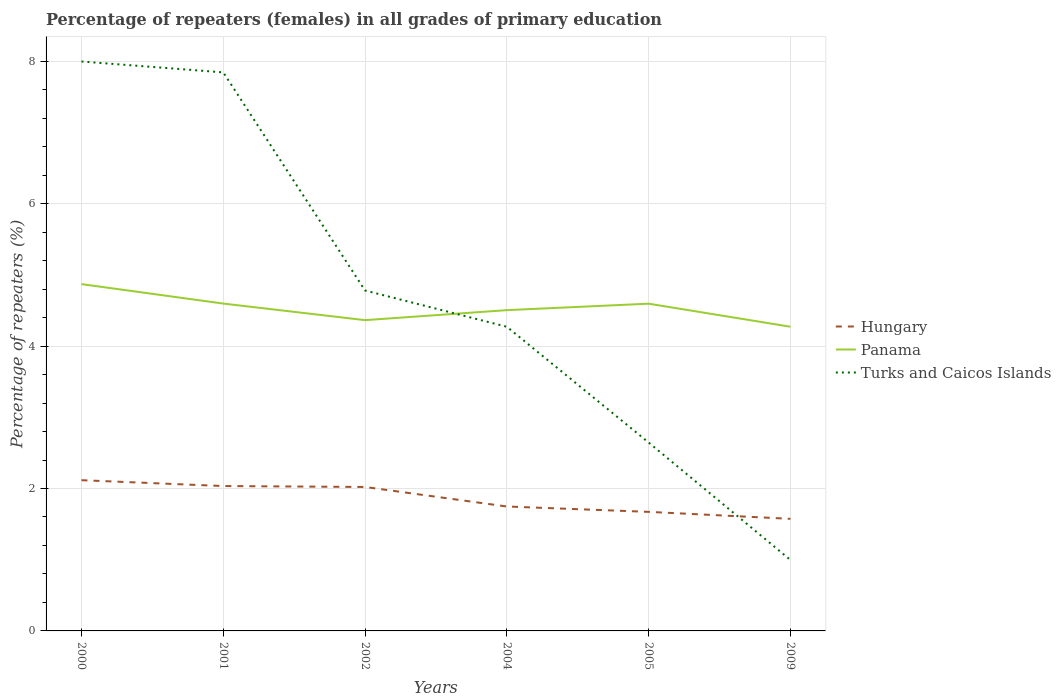Is the number of lines equal to the number of legend labels?
Provide a short and direct response. Yes. Across all years, what is the maximum percentage of repeaters (females) in Panama?
Provide a short and direct response. 4.27. In which year was the percentage of repeaters (females) in Hungary maximum?
Make the answer very short. 2009. What is the total percentage of repeaters (females) in Hungary in the graph?
Provide a short and direct response. 0.45. What is the difference between the highest and the second highest percentage of repeaters (females) in Hungary?
Provide a short and direct response. 0.54. Is the percentage of repeaters (females) in Turks and Caicos Islands strictly greater than the percentage of repeaters (females) in Hungary over the years?
Your answer should be compact. No. How many lines are there?
Your response must be concise. 3. How many years are there in the graph?
Provide a short and direct response. 6. What is the difference between two consecutive major ticks on the Y-axis?
Make the answer very short. 2. Does the graph contain grids?
Make the answer very short. Yes. How many legend labels are there?
Your response must be concise. 3. What is the title of the graph?
Keep it short and to the point. Percentage of repeaters (females) in all grades of primary education. What is the label or title of the X-axis?
Provide a short and direct response. Years. What is the label or title of the Y-axis?
Make the answer very short. Percentage of repeaters (%). What is the Percentage of repeaters (%) of Hungary in 2000?
Offer a terse response. 2.12. What is the Percentage of repeaters (%) in Panama in 2000?
Give a very brief answer. 4.87. What is the Percentage of repeaters (%) of Turks and Caicos Islands in 2000?
Provide a succinct answer. 8. What is the Percentage of repeaters (%) in Hungary in 2001?
Your response must be concise. 2.03. What is the Percentage of repeaters (%) in Panama in 2001?
Give a very brief answer. 4.6. What is the Percentage of repeaters (%) in Turks and Caicos Islands in 2001?
Your answer should be compact. 7.84. What is the Percentage of repeaters (%) of Hungary in 2002?
Offer a very short reply. 2.02. What is the Percentage of repeaters (%) in Panama in 2002?
Give a very brief answer. 4.36. What is the Percentage of repeaters (%) of Turks and Caicos Islands in 2002?
Offer a terse response. 4.78. What is the Percentage of repeaters (%) of Hungary in 2004?
Provide a succinct answer. 1.75. What is the Percentage of repeaters (%) in Panama in 2004?
Give a very brief answer. 4.5. What is the Percentage of repeaters (%) in Turks and Caicos Islands in 2004?
Give a very brief answer. 4.27. What is the Percentage of repeaters (%) in Hungary in 2005?
Ensure brevity in your answer.  1.67. What is the Percentage of repeaters (%) of Panama in 2005?
Ensure brevity in your answer.  4.59. What is the Percentage of repeaters (%) in Turks and Caicos Islands in 2005?
Offer a very short reply. 2.65. What is the Percentage of repeaters (%) in Hungary in 2009?
Your answer should be compact. 1.57. What is the Percentage of repeaters (%) of Panama in 2009?
Give a very brief answer. 4.27. What is the Percentage of repeaters (%) in Turks and Caicos Islands in 2009?
Provide a short and direct response. 1. Across all years, what is the maximum Percentage of repeaters (%) of Hungary?
Your response must be concise. 2.12. Across all years, what is the maximum Percentage of repeaters (%) of Panama?
Your answer should be very brief. 4.87. Across all years, what is the maximum Percentage of repeaters (%) in Turks and Caicos Islands?
Keep it short and to the point. 8. Across all years, what is the minimum Percentage of repeaters (%) in Hungary?
Offer a terse response. 1.57. Across all years, what is the minimum Percentage of repeaters (%) of Panama?
Keep it short and to the point. 4.27. Across all years, what is the minimum Percentage of repeaters (%) of Turks and Caicos Islands?
Your answer should be compact. 1. What is the total Percentage of repeaters (%) in Hungary in the graph?
Keep it short and to the point. 11.17. What is the total Percentage of repeaters (%) in Panama in the graph?
Ensure brevity in your answer.  27.2. What is the total Percentage of repeaters (%) in Turks and Caicos Islands in the graph?
Your answer should be very brief. 28.53. What is the difference between the Percentage of repeaters (%) in Hungary in 2000 and that in 2001?
Your response must be concise. 0.08. What is the difference between the Percentage of repeaters (%) in Panama in 2000 and that in 2001?
Provide a short and direct response. 0.27. What is the difference between the Percentage of repeaters (%) in Turks and Caicos Islands in 2000 and that in 2001?
Provide a succinct answer. 0.15. What is the difference between the Percentage of repeaters (%) of Hungary in 2000 and that in 2002?
Offer a very short reply. 0.1. What is the difference between the Percentage of repeaters (%) in Panama in 2000 and that in 2002?
Your answer should be compact. 0.51. What is the difference between the Percentage of repeaters (%) in Turks and Caicos Islands in 2000 and that in 2002?
Offer a terse response. 3.22. What is the difference between the Percentage of repeaters (%) in Hungary in 2000 and that in 2004?
Your answer should be very brief. 0.37. What is the difference between the Percentage of repeaters (%) of Panama in 2000 and that in 2004?
Provide a short and direct response. 0.37. What is the difference between the Percentage of repeaters (%) of Turks and Caicos Islands in 2000 and that in 2004?
Your answer should be very brief. 3.72. What is the difference between the Percentage of repeaters (%) of Hungary in 2000 and that in 2005?
Make the answer very short. 0.44. What is the difference between the Percentage of repeaters (%) in Panama in 2000 and that in 2005?
Offer a very short reply. 0.27. What is the difference between the Percentage of repeaters (%) in Turks and Caicos Islands in 2000 and that in 2005?
Provide a short and direct response. 5.35. What is the difference between the Percentage of repeaters (%) of Hungary in 2000 and that in 2009?
Make the answer very short. 0.54. What is the difference between the Percentage of repeaters (%) of Panama in 2000 and that in 2009?
Provide a succinct answer. 0.6. What is the difference between the Percentage of repeaters (%) of Turks and Caicos Islands in 2000 and that in 2009?
Make the answer very short. 7. What is the difference between the Percentage of repeaters (%) in Hungary in 2001 and that in 2002?
Make the answer very short. 0.01. What is the difference between the Percentage of repeaters (%) in Panama in 2001 and that in 2002?
Your answer should be compact. 0.23. What is the difference between the Percentage of repeaters (%) of Turks and Caicos Islands in 2001 and that in 2002?
Give a very brief answer. 3.06. What is the difference between the Percentage of repeaters (%) of Hungary in 2001 and that in 2004?
Ensure brevity in your answer.  0.29. What is the difference between the Percentage of repeaters (%) of Panama in 2001 and that in 2004?
Your answer should be very brief. 0.09. What is the difference between the Percentage of repeaters (%) of Turks and Caicos Islands in 2001 and that in 2004?
Keep it short and to the point. 3.57. What is the difference between the Percentage of repeaters (%) in Hungary in 2001 and that in 2005?
Provide a succinct answer. 0.36. What is the difference between the Percentage of repeaters (%) in Panama in 2001 and that in 2005?
Offer a terse response. 0. What is the difference between the Percentage of repeaters (%) in Turks and Caicos Islands in 2001 and that in 2005?
Ensure brevity in your answer.  5.2. What is the difference between the Percentage of repeaters (%) in Hungary in 2001 and that in 2009?
Keep it short and to the point. 0.46. What is the difference between the Percentage of repeaters (%) in Panama in 2001 and that in 2009?
Offer a very short reply. 0.33. What is the difference between the Percentage of repeaters (%) in Turks and Caicos Islands in 2001 and that in 2009?
Make the answer very short. 6.85. What is the difference between the Percentage of repeaters (%) in Hungary in 2002 and that in 2004?
Give a very brief answer. 0.27. What is the difference between the Percentage of repeaters (%) of Panama in 2002 and that in 2004?
Provide a short and direct response. -0.14. What is the difference between the Percentage of repeaters (%) of Turks and Caicos Islands in 2002 and that in 2004?
Provide a succinct answer. 0.51. What is the difference between the Percentage of repeaters (%) of Hungary in 2002 and that in 2005?
Your answer should be compact. 0.35. What is the difference between the Percentage of repeaters (%) of Panama in 2002 and that in 2005?
Make the answer very short. -0.23. What is the difference between the Percentage of repeaters (%) of Turks and Caicos Islands in 2002 and that in 2005?
Offer a very short reply. 2.13. What is the difference between the Percentage of repeaters (%) in Hungary in 2002 and that in 2009?
Your response must be concise. 0.45. What is the difference between the Percentage of repeaters (%) of Panama in 2002 and that in 2009?
Ensure brevity in your answer.  0.09. What is the difference between the Percentage of repeaters (%) of Turks and Caicos Islands in 2002 and that in 2009?
Your answer should be compact. 3.78. What is the difference between the Percentage of repeaters (%) of Hungary in 2004 and that in 2005?
Make the answer very short. 0.08. What is the difference between the Percentage of repeaters (%) in Panama in 2004 and that in 2005?
Your answer should be very brief. -0.09. What is the difference between the Percentage of repeaters (%) of Turks and Caicos Islands in 2004 and that in 2005?
Provide a short and direct response. 1.63. What is the difference between the Percentage of repeaters (%) in Hungary in 2004 and that in 2009?
Offer a very short reply. 0.17. What is the difference between the Percentage of repeaters (%) in Panama in 2004 and that in 2009?
Provide a succinct answer. 0.23. What is the difference between the Percentage of repeaters (%) in Turks and Caicos Islands in 2004 and that in 2009?
Your answer should be very brief. 3.27. What is the difference between the Percentage of repeaters (%) of Hungary in 2005 and that in 2009?
Make the answer very short. 0.1. What is the difference between the Percentage of repeaters (%) of Panama in 2005 and that in 2009?
Provide a succinct answer. 0.32. What is the difference between the Percentage of repeaters (%) in Turks and Caicos Islands in 2005 and that in 2009?
Your answer should be very brief. 1.65. What is the difference between the Percentage of repeaters (%) in Hungary in 2000 and the Percentage of repeaters (%) in Panama in 2001?
Offer a terse response. -2.48. What is the difference between the Percentage of repeaters (%) in Hungary in 2000 and the Percentage of repeaters (%) in Turks and Caicos Islands in 2001?
Keep it short and to the point. -5.73. What is the difference between the Percentage of repeaters (%) in Panama in 2000 and the Percentage of repeaters (%) in Turks and Caicos Islands in 2001?
Give a very brief answer. -2.97. What is the difference between the Percentage of repeaters (%) in Hungary in 2000 and the Percentage of repeaters (%) in Panama in 2002?
Give a very brief answer. -2.25. What is the difference between the Percentage of repeaters (%) of Hungary in 2000 and the Percentage of repeaters (%) of Turks and Caicos Islands in 2002?
Ensure brevity in your answer.  -2.66. What is the difference between the Percentage of repeaters (%) of Panama in 2000 and the Percentage of repeaters (%) of Turks and Caicos Islands in 2002?
Your answer should be compact. 0.09. What is the difference between the Percentage of repeaters (%) of Hungary in 2000 and the Percentage of repeaters (%) of Panama in 2004?
Your answer should be compact. -2.39. What is the difference between the Percentage of repeaters (%) of Hungary in 2000 and the Percentage of repeaters (%) of Turks and Caicos Islands in 2004?
Offer a terse response. -2.15. What is the difference between the Percentage of repeaters (%) in Panama in 2000 and the Percentage of repeaters (%) in Turks and Caicos Islands in 2004?
Ensure brevity in your answer.  0.6. What is the difference between the Percentage of repeaters (%) of Hungary in 2000 and the Percentage of repeaters (%) of Panama in 2005?
Your answer should be very brief. -2.48. What is the difference between the Percentage of repeaters (%) of Hungary in 2000 and the Percentage of repeaters (%) of Turks and Caicos Islands in 2005?
Offer a very short reply. -0.53. What is the difference between the Percentage of repeaters (%) in Panama in 2000 and the Percentage of repeaters (%) in Turks and Caicos Islands in 2005?
Provide a succinct answer. 2.22. What is the difference between the Percentage of repeaters (%) of Hungary in 2000 and the Percentage of repeaters (%) of Panama in 2009?
Your response must be concise. -2.15. What is the difference between the Percentage of repeaters (%) in Hungary in 2000 and the Percentage of repeaters (%) in Turks and Caicos Islands in 2009?
Offer a very short reply. 1.12. What is the difference between the Percentage of repeaters (%) of Panama in 2000 and the Percentage of repeaters (%) of Turks and Caicos Islands in 2009?
Your answer should be very brief. 3.87. What is the difference between the Percentage of repeaters (%) in Hungary in 2001 and the Percentage of repeaters (%) in Panama in 2002?
Your answer should be compact. -2.33. What is the difference between the Percentage of repeaters (%) of Hungary in 2001 and the Percentage of repeaters (%) of Turks and Caicos Islands in 2002?
Your answer should be very brief. -2.75. What is the difference between the Percentage of repeaters (%) in Panama in 2001 and the Percentage of repeaters (%) in Turks and Caicos Islands in 2002?
Offer a very short reply. -0.18. What is the difference between the Percentage of repeaters (%) of Hungary in 2001 and the Percentage of repeaters (%) of Panama in 2004?
Your answer should be very brief. -2.47. What is the difference between the Percentage of repeaters (%) of Hungary in 2001 and the Percentage of repeaters (%) of Turks and Caicos Islands in 2004?
Keep it short and to the point. -2.24. What is the difference between the Percentage of repeaters (%) in Panama in 2001 and the Percentage of repeaters (%) in Turks and Caicos Islands in 2004?
Provide a short and direct response. 0.33. What is the difference between the Percentage of repeaters (%) of Hungary in 2001 and the Percentage of repeaters (%) of Panama in 2005?
Offer a terse response. -2.56. What is the difference between the Percentage of repeaters (%) of Hungary in 2001 and the Percentage of repeaters (%) of Turks and Caicos Islands in 2005?
Make the answer very short. -0.61. What is the difference between the Percentage of repeaters (%) in Panama in 2001 and the Percentage of repeaters (%) in Turks and Caicos Islands in 2005?
Your answer should be compact. 1.95. What is the difference between the Percentage of repeaters (%) in Hungary in 2001 and the Percentage of repeaters (%) in Panama in 2009?
Keep it short and to the point. -2.24. What is the difference between the Percentage of repeaters (%) in Hungary in 2001 and the Percentage of repeaters (%) in Turks and Caicos Islands in 2009?
Your answer should be compact. 1.04. What is the difference between the Percentage of repeaters (%) in Panama in 2001 and the Percentage of repeaters (%) in Turks and Caicos Islands in 2009?
Provide a short and direct response. 3.6. What is the difference between the Percentage of repeaters (%) in Hungary in 2002 and the Percentage of repeaters (%) in Panama in 2004?
Your answer should be very brief. -2.48. What is the difference between the Percentage of repeaters (%) of Hungary in 2002 and the Percentage of repeaters (%) of Turks and Caicos Islands in 2004?
Give a very brief answer. -2.25. What is the difference between the Percentage of repeaters (%) in Panama in 2002 and the Percentage of repeaters (%) in Turks and Caicos Islands in 2004?
Your answer should be compact. 0.09. What is the difference between the Percentage of repeaters (%) of Hungary in 2002 and the Percentage of repeaters (%) of Panama in 2005?
Make the answer very short. -2.57. What is the difference between the Percentage of repeaters (%) of Hungary in 2002 and the Percentage of repeaters (%) of Turks and Caicos Islands in 2005?
Provide a succinct answer. -0.62. What is the difference between the Percentage of repeaters (%) of Panama in 2002 and the Percentage of repeaters (%) of Turks and Caicos Islands in 2005?
Offer a terse response. 1.72. What is the difference between the Percentage of repeaters (%) in Hungary in 2002 and the Percentage of repeaters (%) in Panama in 2009?
Keep it short and to the point. -2.25. What is the difference between the Percentage of repeaters (%) in Hungary in 2002 and the Percentage of repeaters (%) in Turks and Caicos Islands in 2009?
Make the answer very short. 1.02. What is the difference between the Percentage of repeaters (%) of Panama in 2002 and the Percentage of repeaters (%) of Turks and Caicos Islands in 2009?
Make the answer very short. 3.37. What is the difference between the Percentage of repeaters (%) in Hungary in 2004 and the Percentage of repeaters (%) in Panama in 2005?
Provide a short and direct response. -2.85. What is the difference between the Percentage of repeaters (%) of Hungary in 2004 and the Percentage of repeaters (%) of Turks and Caicos Islands in 2005?
Your response must be concise. -0.9. What is the difference between the Percentage of repeaters (%) in Panama in 2004 and the Percentage of repeaters (%) in Turks and Caicos Islands in 2005?
Provide a succinct answer. 1.86. What is the difference between the Percentage of repeaters (%) in Hungary in 2004 and the Percentage of repeaters (%) in Panama in 2009?
Provide a succinct answer. -2.52. What is the difference between the Percentage of repeaters (%) in Hungary in 2004 and the Percentage of repeaters (%) in Turks and Caicos Islands in 2009?
Your answer should be compact. 0.75. What is the difference between the Percentage of repeaters (%) of Panama in 2004 and the Percentage of repeaters (%) of Turks and Caicos Islands in 2009?
Make the answer very short. 3.51. What is the difference between the Percentage of repeaters (%) in Hungary in 2005 and the Percentage of repeaters (%) in Panama in 2009?
Offer a very short reply. -2.6. What is the difference between the Percentage of repeaters (%) in Hungary in 2005 and the Percentage of repeaters (%) in Turks and Caicos Islands in 2009?
Offer a very short reply. 0.68. What is the difference between the Percentage of repeaters (%) in Panama in 2005 and the Percentage of repeaters (%) in Turks and Caicos Islands in 2009?
Give a very brief answer. 3.6. What is the average Percentage of repeaters (%) in Hungary per year?
Provide a succinct answer. 1.86. What is the average Percentage of repeaters (%) of Panama per year?
Provide a short and direct response. 4.53. What is the average Percentage of repeaters (%) in Turks and Caicos Islands per year?
Your response must be concise. 4.76. In the year 2000, what is the difference between the Percentage of repeaters (%) of Hungary and Percentage of repeaters (%) of Panama?
Give a very brief answer. -2.75. In the year 2000, what is the difference between the Percentage of repeaters (%) in Hungary and Percentage of repeaters (%) in Turks and Caicos Islands?
Your answer should be compact. -5.88. In the year 2000, what is the difference between the Percentage of repeaters (%) of Panama and Percentage of repeaters (%) of Turks and Caicos Islands?
Provide a succinct answer. -3.13. In the year 2001, what is the difference between the Percentage of repeaters (%) in Hungary and Percentage of repeaters (%) in Panama?
Offer a terse response. -2.56. In the year 2001, what is the difference between the Percentage of repeaters (%) in Hungary and Percentage of repeaters (%) in Turks and Caicos Islands?
Your response must be concise. -5.81. In the year 2001, what is the difference between the Percentage of repeaters (%) in Panama and Percentage of repeaters (%) in Turks and Caicos Islands?
Keep it short and to the point. -3.25. In the year 2002, what is the difference between the Percentage of repeaters (%) of Hungary and Percentage of repeaters (%) of Panama?
Your answer should be very brief. -2.34. In the year 2002, what is the difference between the Percentage of repeaters (%) of Hungary and Percentage of repeaters (%) of Turks and Caicos Islands?
Offer a very short reply. -2.76. In the year 2002, what is the difference between the Percentage of repeaters (%) in Panama and Percentage of repeaters (%) in Turks and Caicos Islands?
Your response must be concise. -0.42. In the year 2004, what is the difference between the Percentage of repeaters (%) of Hungary and Percentage of repeaters (%) of Panama?
Your response must be concise. -2.76. In the year 2004, what is the difference between the Percentage of repeaters (%) of Hungary and Percentage of repeaters (%) of Turks and Caicos Islands?
Provide a short and direct response. -2.52. In the year 2004, what is the difference between the Percentage of repeaters (%) in Panama and Percentage of repeaters (%) in Turks and Caicos Islands?
Provide a short and direct response. 0.23. In the year 2005, what is the difference between the Percentage of repeaters (%) in Hungary and Percentage of repeaters (%) in Panama?
Your response must be concise. -2.92. In the year 2005, what is the difference between the Percentage of repeaters (%) of Hungary and Percentage of repeaters (%) of Turks and Caicos Islands?
Your answer should be compact. -0.97. In the year 2005, what is the difference between the Percentage of repeaters (%) in Panama and Percentage of repeaters (%) in Turks and Caicos Islands?
Your response must be concise. 1.95. In the year 2009, what is the difference between the Percentage of repeaters (%) of Hungary and Percentage of repeaters (%) of Panama?
Offer a terse response. -2.7. In the year 2009, what is the difference between the Percentage of repeaters (%) of Hungary and Percentage of repeaters (%) of Turks and Caicos Islands?
Offer a terse response. 0.58. In the year 2009, what is the difference between the Percentage of repeaters (%) in Panama and Percentage of repeaters (%) in Turks and Caicos Islands?
Offer a terse response. 3.27. What is the ratio of the Percentage of repeaters (%) in Hungary in 2000 to that in 2001?
Offer a very short reply. 1.04. What is the ratio of the Percentage of repeaters (%) in Panama in 2000 to that in 2001?
Offer a very short reply. 1.06. What is the ratio of the Percentage of repeaters (%) of Turks and Caicos Islands in 2000 to that in 2001?
Offer a terse response. 1.02. What is the ratio of the Percentage of repeaters (%) of Hungary in 2000 to that in 2002?
Offer a very short reply. 1.05. What is the ratio of the Percentage of repeaters (%) of Panama in 2000 to that in 2002?
Offer a very short reply. 1.12. What is the ratio of the Percentage of repeaters (%) in Turks and Caicos Islands in 2000 to that in 2002?
Provide a short and direct response. 1.67. What is the ratio of the Percentage of repeaters (%) in Hungary in 2000 to that in 2004?
Keep it short and to the point. 1.21. What is the ratio of the Percentage of repeaters (%) in Panama in 2000 to that in 2004?
Give a very brief answer. 1.08. What is the ratio of the Percentage of repeaters (%) of Turks and Caicos Islands in 2000 to that in 2004?
Your answer should be compact. 1.87. What is the ratio of the Percentage of repeaters (%) of Hungary in 2000 to that in 2005?
Keep it short and to the point. 1.27. What is the ratio of the Percentage of repeaters (%) of Panama in 2000 to that in 2005?
Your answer should be compact. 1.06. What is the ratio of the Percentage of repeaters (%) in Turks and Caicos Islands in 2000 to that in 2005?
Provide a short and direct response. 3.02. What is the ratio of the Percentage of repeaters (%) of Hungary in 2000 to that in 2009?
Provide a succinct answer. 1.34. What is the ratio of the Percentage of repeaters (%) of Panama in 2000 to that in 2009?
Your answer should be compact. 1.14. What is the ratio of the Percentage of repeaters (%) in Turks and Caicos Islands in 2000 to that in 2009?
Your answer should be very brief. 8.02. What is the ratio of the Percentage of repeaters (%) in Hungary in 2001 to that in 2002?
Ensure brevity in your answer.  1.01. What is the ratio of the Percentage of repeaters (%) of Panama in 2001 to that in 2002?
Your response must be concise. 1.05. What is the ratio of the Percentage of repeaters (%) of Turks and Caicos Islands in 2001 to that in 2002?
Your answer should be compact. 1.64. What is the ratio of the Percentage of repeaters (%) in Hungary in 2001 to that in 2004?
Give a very brief answer. 1.16. What is the ratio of the Percentage of repeaters (%) in Panama in 2001 to that in 2004?
Ensure brevity in your answer.  1.02. What is the ratio of the Percentage of repeaters (%) in Turks and Caicos Islands in 2001 to that in 2004?
Offer a very short reply. 1.84. What is the ratio of the Percentage of repeaters (%) in Hungary in 2001 to that in 2005?
Make the answer very short. 1.22. What is the ratio of the Percentage of repeaters (%) of Panama in 2001 to that in 2005?
Offer a terse response. 1. What is the ratio of the Percentage of repeaters (%) of Turks and Caicos Islands in 2001 to that in 2005?
Your answer should be very brief. 2.96. What is the ratio of the Percentage of repeaters (%) in Hungary in 2001 to that in 2009?
Ensure brevity in your answer.  1.29. What is the ratio of the Percentage of repeaters (%) of Panama in 2001 to that in 2009?
Offer a very short reply. 1.08. What is the ratio of the Percentage of repeaters (%) in Turks and Caicos Islands in 2001 to that in 2009?
Provide a succinct answer. 7.87. What is the ratio of the Percentage of repeaters (%) of Hungary in 2002 to that in 2004?
Provide a succinct answer. 1.16. What is the ratio of the Percentage of repeaters (%) in Panama in 2002 to that in 2004?
Keep it short and to the point. 0.97. What is the ratio of the Percentage of repeaters (%) in Turks and Caicos Islands in 2002 to that in 2004?
Provide a succinct answer. 1.12. What is the ratio of the Percentage of repeaters (%) of Hungary in 2002 to that in 2005?
Provide a short and direct response. 1.21. What is the ratio of the Percentage of repeaters (%) in Panama in 2002 to that in 2005?
Provide a succinct answer. 0.95. What is the ratio of the Percentage of repeaters (%) in Turks and Caicos Islands in 2002 to that in 2005?
Your answer should be very brief. 1.81. What is the ratio of the Percentage of repeaters (%) of Hungary in 2002 to that in 2009?
Provide a short and direct response. 1.28. What is the ratio of the Percentage of repeaters (%) of Panama in 2002 to that in 2009?
Your response must be concise. 1.02. What is the ratio of the Percentage of repeaters (%) in Turks and Caicos Islands in 2002 to that in 2009?
Offer a very short reply. 4.8. What is the ratio of the Percentage of repeaters (%) in Hungary in 2004 to that in 2005?
Keep it short and to the point. 1.04. What is the ratio of the Percentage of repeaters (%) of Panama in 2004 to that in 2005?
Offer a terse response. 0.98. What is the ratio of the Percentage of repeaters (%) in Turks and Caicos Islands in 2004 to that in 2005?
Ensure brevity in your answer.  1.61. What is the ratio of the Percentage of repeaters (%) of Hungary in 2004 to that in 2009?
Provide a succinct answer. 1.11. What is the ratio of the Percentage of repeaters (%) of Panama in 2004 to that in 2009?
Make the answer very short. 1.05. What is the ratio of the Percentage of repeaters (%) of Turks and Caicos Islands in 2004 to that in 2009?
Provide a short and direct response. 4.29. What is the ratio of the Percentage of repeaters (%) of Hungary in 2005 to that in 2009?
Your response must be concise. 1.06. What is the ratio of the Percentage of repeaters (%) in Panama in 2005 to that in 2009?
Provide a short and direct response. 1.08. What is the ratio of the Percentage of repeaters (%) of Turks and Caicos Islands in 2005 to that in 2009?
Provide a succinct answer. 2.65. What is the difference between the highest and the second highest Percentage of repeaters (%) of Hungary?
Provide a succinct answer. 0.08. What is the difference between the highest and the second highest Percentage of repeaters (%) in Panama?
Your response must be concise. 0.27. What is the difference between the highest and the second highest Percentage of repeaters (%) of Turks and Caicos Islands?
Offer a terse response. 0.15. What is the difference between the highest and the lowest Percentage of repeaters (%) of Hungary?
Give a very brief answer. 0.54. What is the difference between the highest and the lowest Percentage of repeaters (%) of Panama?
Keep it short and to the point. 0.6. What is the difference between the highest and the lowest Percentage of repeaters (%) in Turks and Caicos Islands?
Provide a succinct answer. 7. 